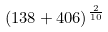<formula> <loc_0><loc_0><loc_500><loc_500>( 1 3 8 + 4 0 6 ) ^ { \frac { 2 } { 1 0 } }</formula> 